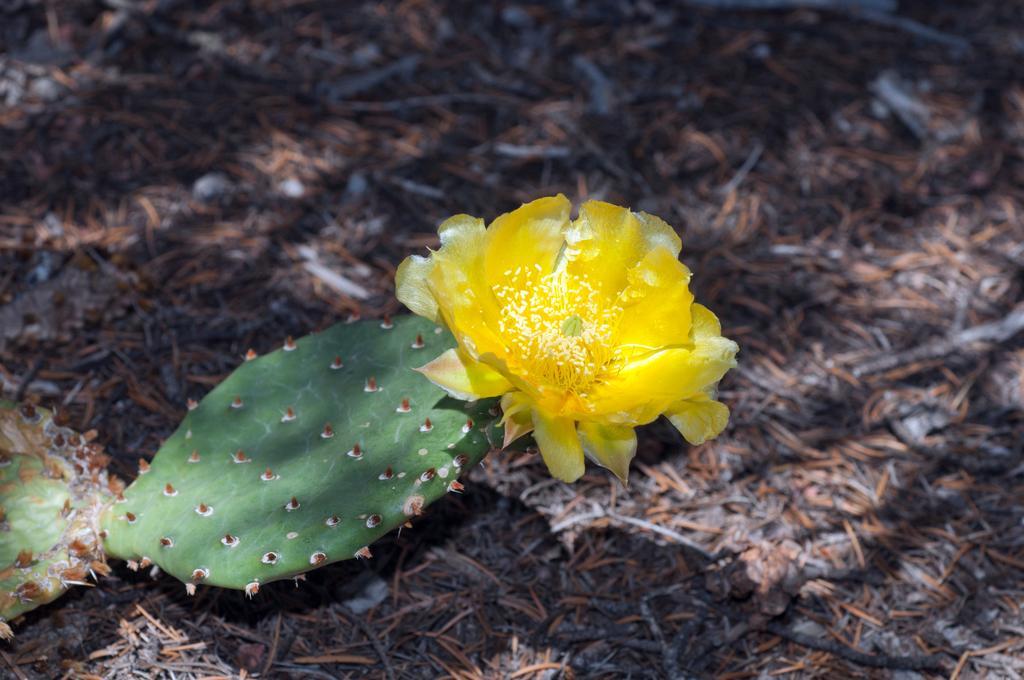Can you describe this image briefly? The picture consists of dry leaves, cactus plant and flower. At the top it is blurred. 